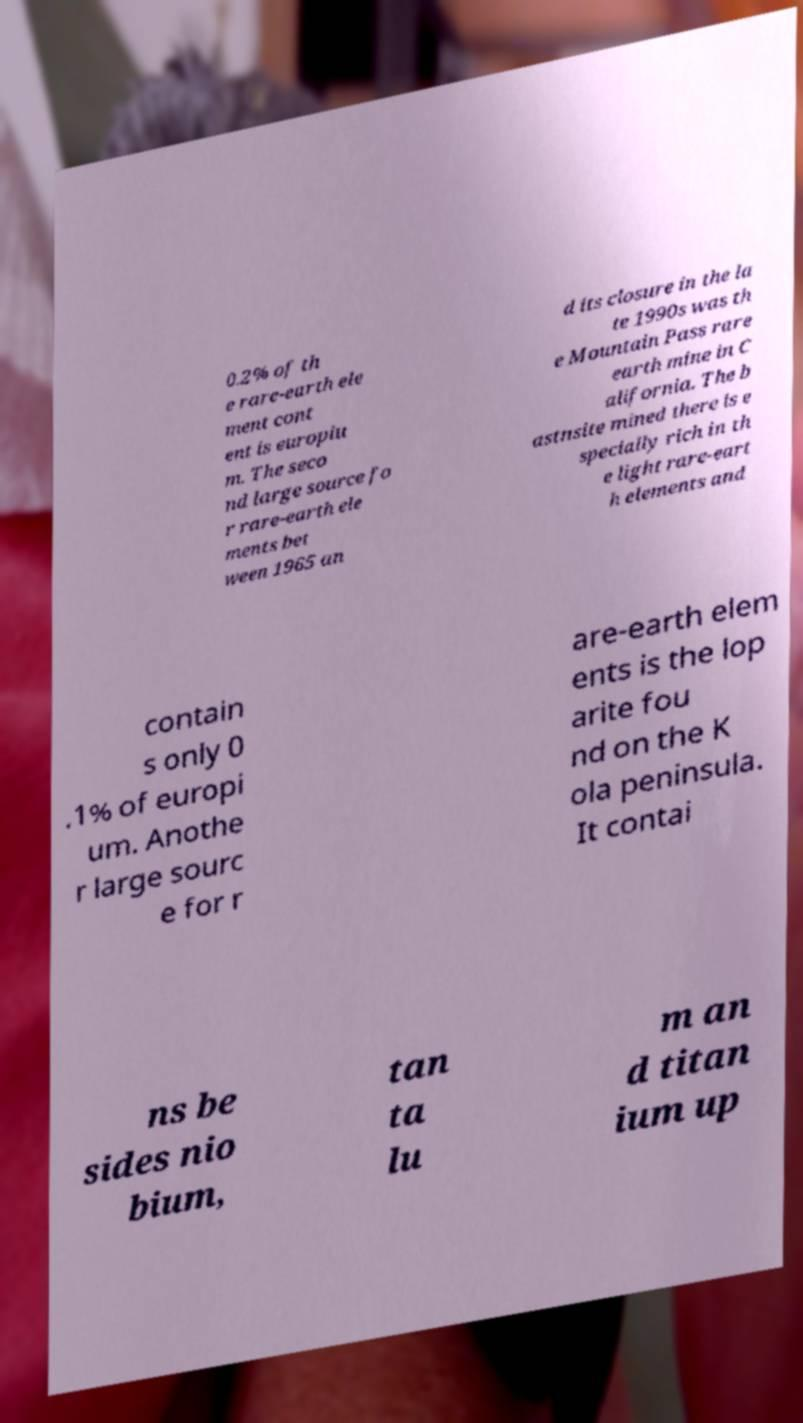Could you extract and type out the text from this image? 0.2% of th e rare-earth ele ment cont ent is europiu m. The seco nd large source fo r rare-earth ele ments bet ween 1965 an d its closure in the la te 1990s was th e Mountain Pass rare earth mine in C alifornia. The b astnsite mined there is e specially rich in th e light rare-eart h elements and contain s only 0 .1% of europi um. Anothe r large sourc e for r are-earth elem ents is the lop arite fou nd on the K ola peninsula. It contai ns be sides nio bium, tan ta lu m an d titan ium up 